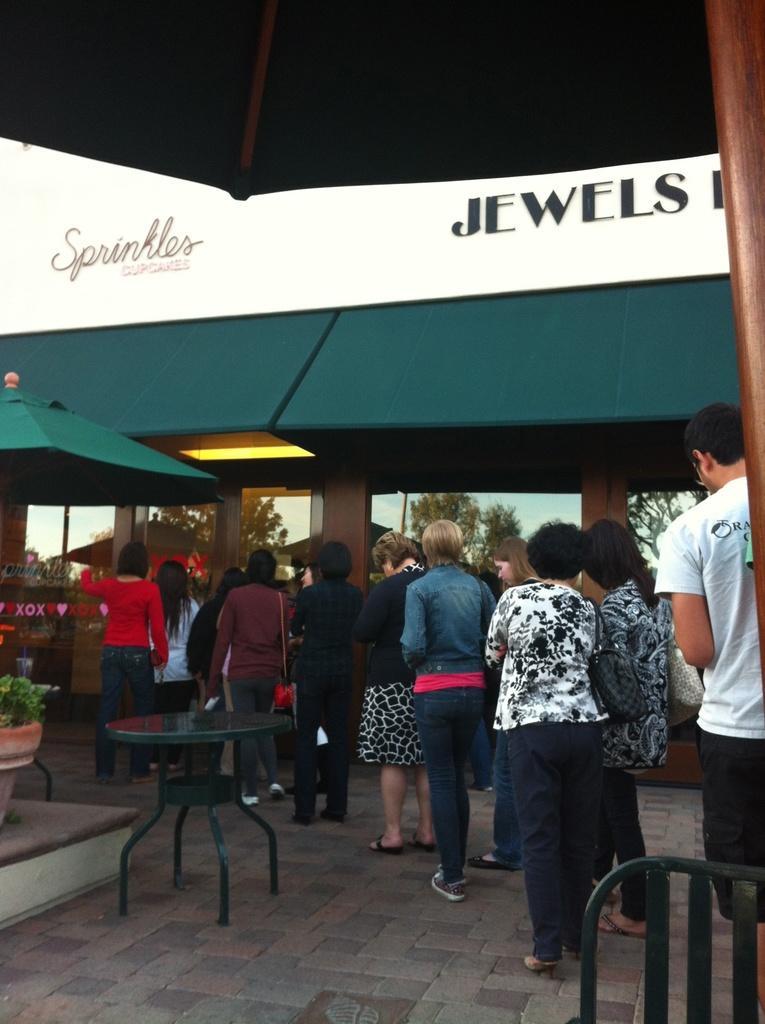Describe this image in one or two sentences. In the image there are group of people who are standing. On left side there is a table and we can also see a plants and flower pot on left side. On right side we can see a chair in middle there is a door,trees and sky on top. 